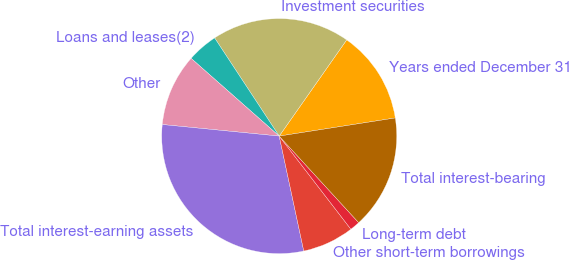Convert chart to OTSL. <chart><loc_0><loc_0><loc_500><loc_500><pie_chart><fcel>Years ended December 31<fcel>Investment securities<fcel>Loans and leases(2)<fcel>Other<fcel>Total interest-earning assets<fcel>Other short-term borrowings<fcel>Long-term debt<fcel>Total interest-bearing<nl><fcel>12.8%<fcel>19.0%<fcel>4.23%<fcel>9.94%<fcel>29.93%<fcel>7.09%<fcel>1.38%<fcel>15.65%<nl></chart> 